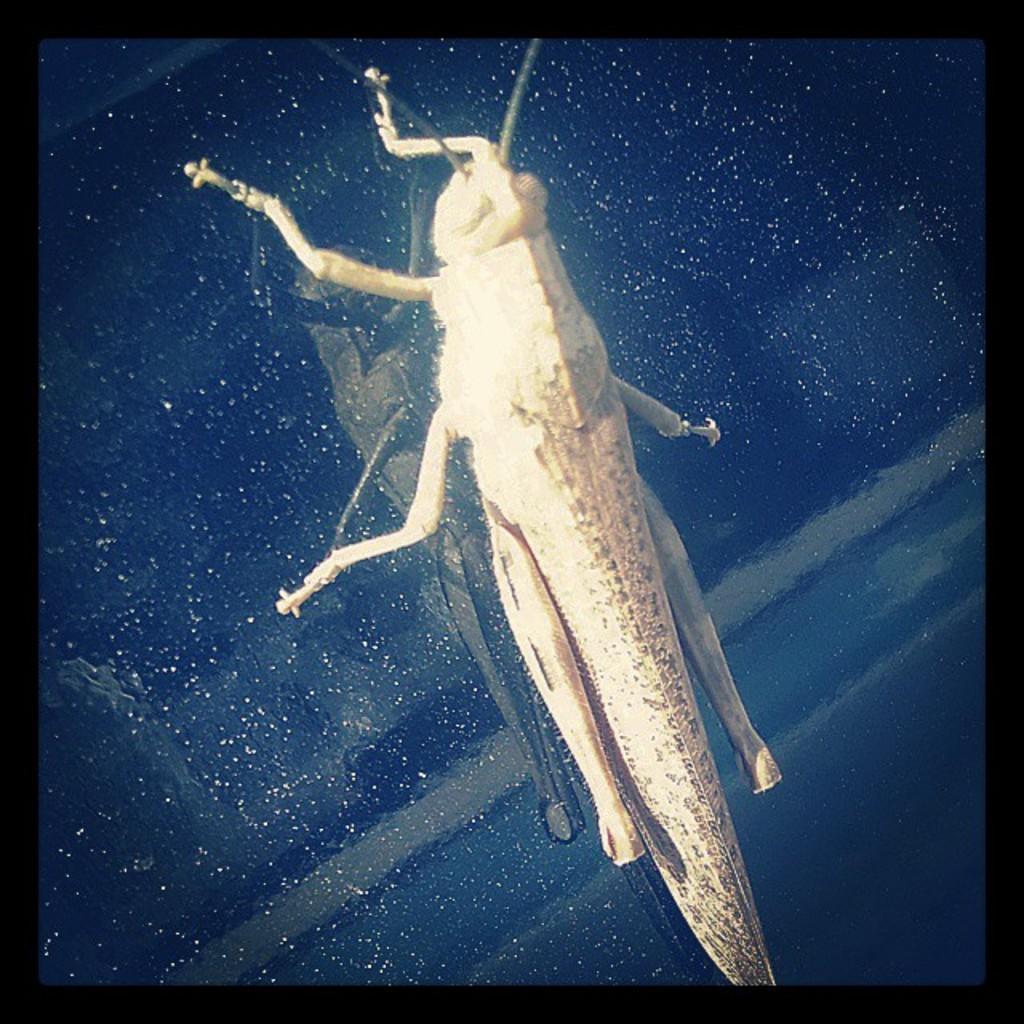Please provide a concise description of this image. In the image we can see a insect, on a glass window. 